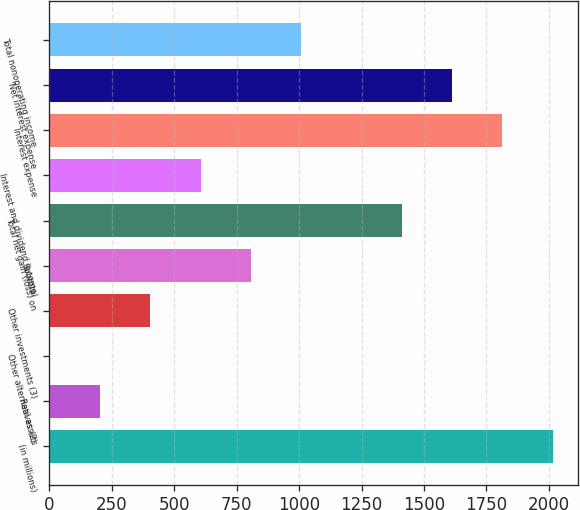Convert chart to OTSL. <chart><loc_0><loc_0><loc_500><loc_500><bar_chart><fcel>(in millions)<fcel>Real assets<fcel>Other alternatives (2)<fcel>Other investments (3)<fcel>Subtotal<fcel>Total net gain (loss) on<fcel>Interest and dividend income<fcel>Interest expense<fcel>Net interest expense<fcel>Total nonoperating income<nl><fcel>2015<fcel>203.3<fcel>2<fcel>404.6<fcel>807.2<fcel>1411.1<fcel>605.9<fcel>1813.7<fcel>1612.4<fcel>1008.5<nl></chart> 